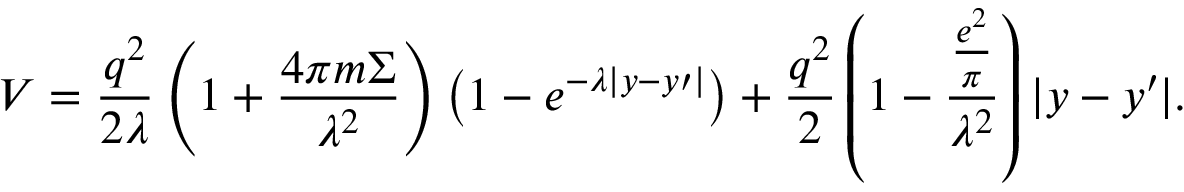<formula> <loc_0><loc_0><loc_500><loc_500>V = \frac { { q ^ { 2 } } } { 2 \lambda } \left ( { 1 + \frac { 4 \pi m \Sigma } { { \lambda ^ { 2 } } } } \right ) \left ( { 1 - e ^ { - \lambda | y - y { \prime } | } } \right ) + \frac { { q ^ { 2 } } } { 2 } \left ( { 1 - \frac { { \frac { { e ^ { 2 } } } { \pi } } } { { \lambda ^ { 2 } } } } \right ) | y - y { \prime } | .</formula> 